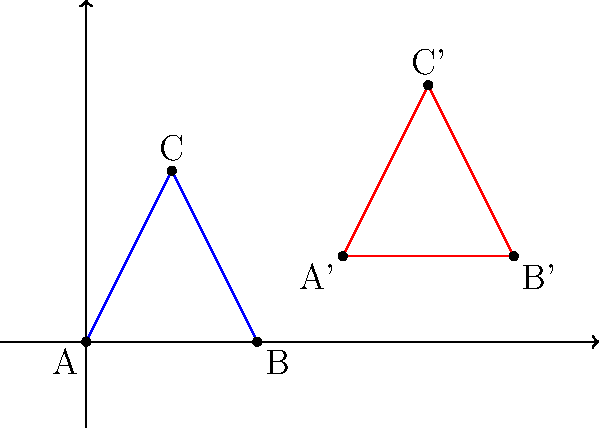In the context of NBN HFC Platform design, consider the blue triangle ABC and its transformed red counterpart A'B'C'. Identify the sequence of transformations that maps triangle ABC onto triangle A'B'C'. Express your answer as a series of transformation operations. To determine the sequence of transformations, let's analyze the changes step-by-step:

1. Translation:
   The entire triangle has moved to the right and up. We can calculate this translation:
   - x-direction: A' - A = (3,1) - (0,0) = 3 units right
   - y-direction: A' - A = (3,1) - (0,0) = 1 unit up
   So, the first transformation is a translation of (3,1).

2. Rotation:
   After translation, we notice that the triangle has been rotated. To determine the angle:
   - Original slope of AB: (0-0)/(2-0) = 0
   - New slope of A'B': (1-1)/(5-3) = 0
   The slopes are the same, indicating no rotation.

3. Reflection:
   The triangle appears to be reflected over a horizontal line. This can be confirmed by checking the y-coordinates:
   - A to A': 0 to 1
   - B to B': 0 to 1
   - C to C': 2 to 3
   Each point has moved up by 1 unit, consistent with the initial translation and a reflection over y = 0.5.

4. Dilation:
   The triangle maintains its shape and proportions, so there is no dilation.

Therefore, the sequence of transformations is:
1. Translate by (3,1)
2. Reflect over the line y = 0.5
Answer: Translate(3,1) → Reflect(y=0.5) 